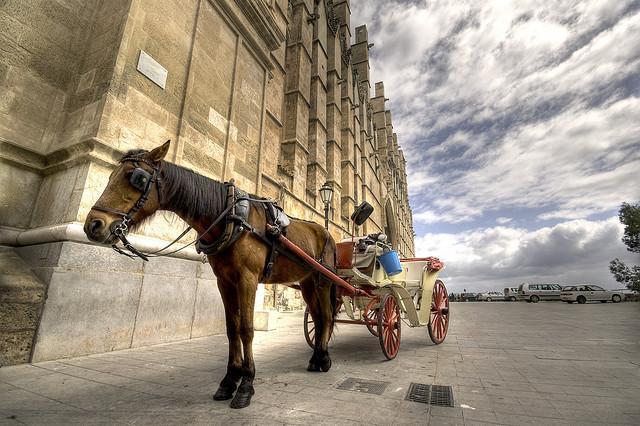How many stripes does the coffee cup have?
Give a very brief answer. 0. 